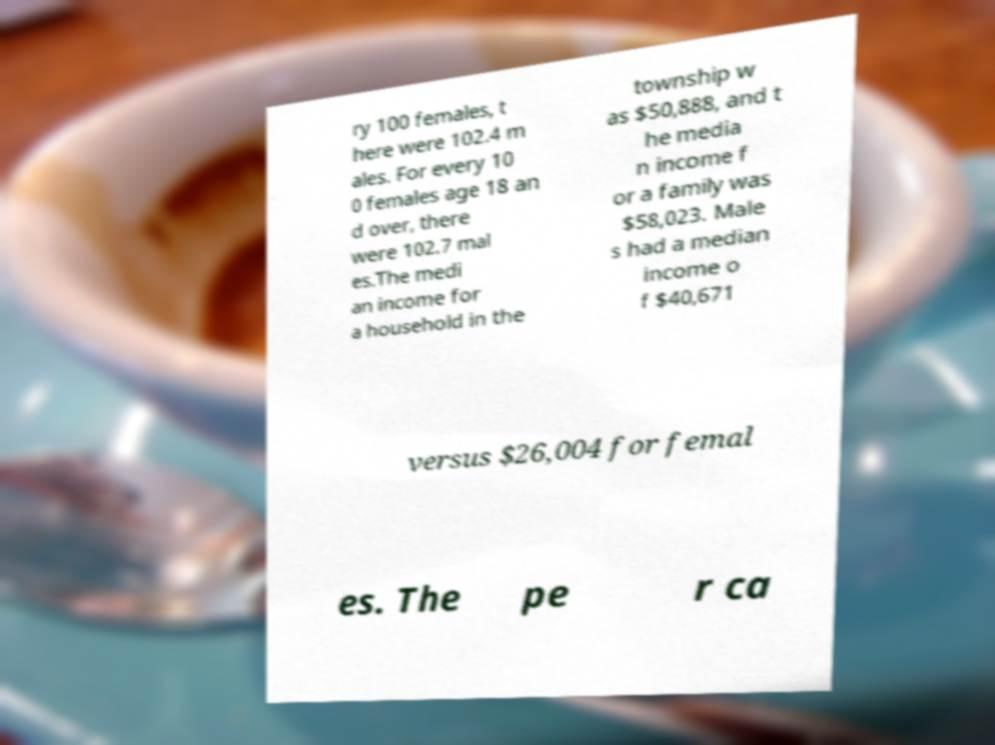What messages or text are displayed in this image? I need them in a readable, typed format. ry 100 females, t here were 102.4 m ales. For every 10 0 females age 18 an d over, there were 102.7 mal es.The medi an income for a household in the township w as $50,888, and t he media n income f or a family was $58,023. Male s had a median income o f $40,671 versus $26,004 for femal es. The pe r ca 